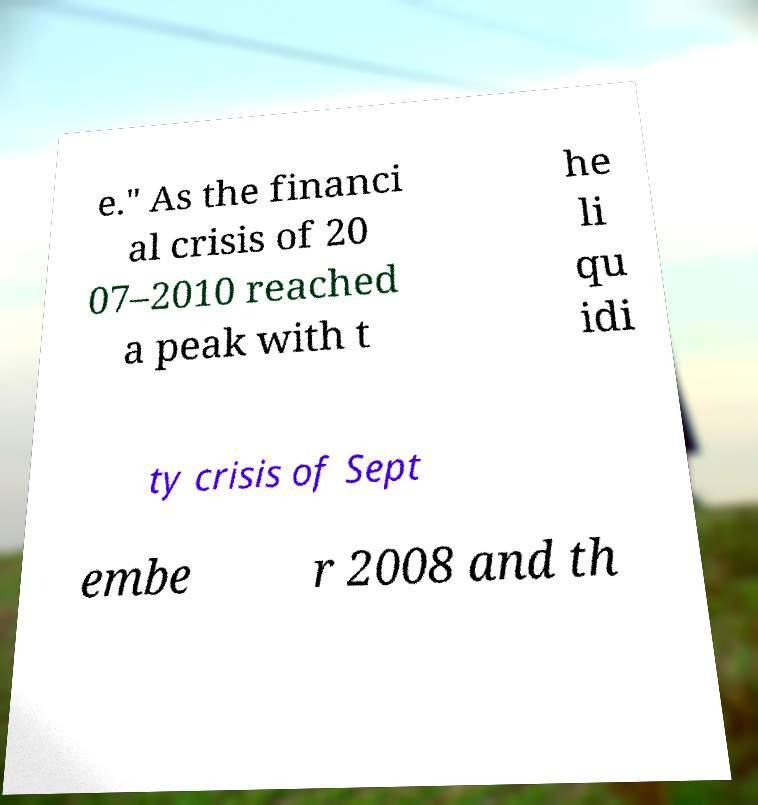Please identify and transcribe the text found in this image. e." As the financi al crisis of 20 07–2010 reached a peak with t he li qu idi ty crisis of Sept embe r 2008 and th 